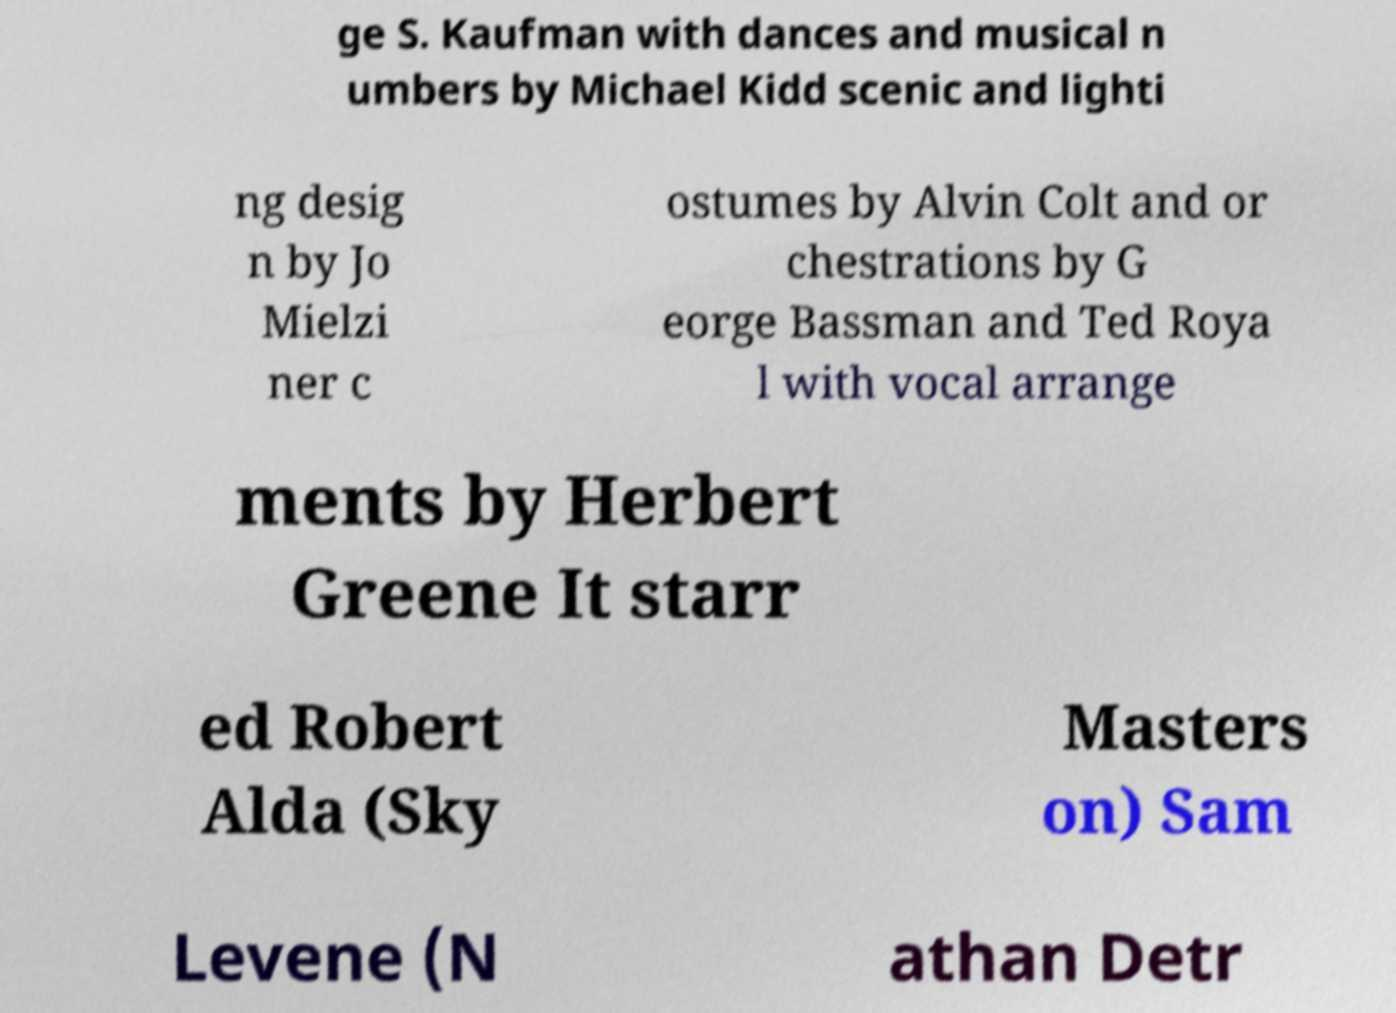Could you extract and type out the text from this image? ge S. Kaufman with dances and musical n umbers by Michael Kidd scenic and lighti ng desig n by Jo Mielzi ner c ostumes by Alvin Colt and or chestrations by G eorge Bassman and Ted Roya l with vocal arrange ments by Herbert Greene It starr ed Robert Alda (Sky Masters on) Sam Levene (N athan Detr 